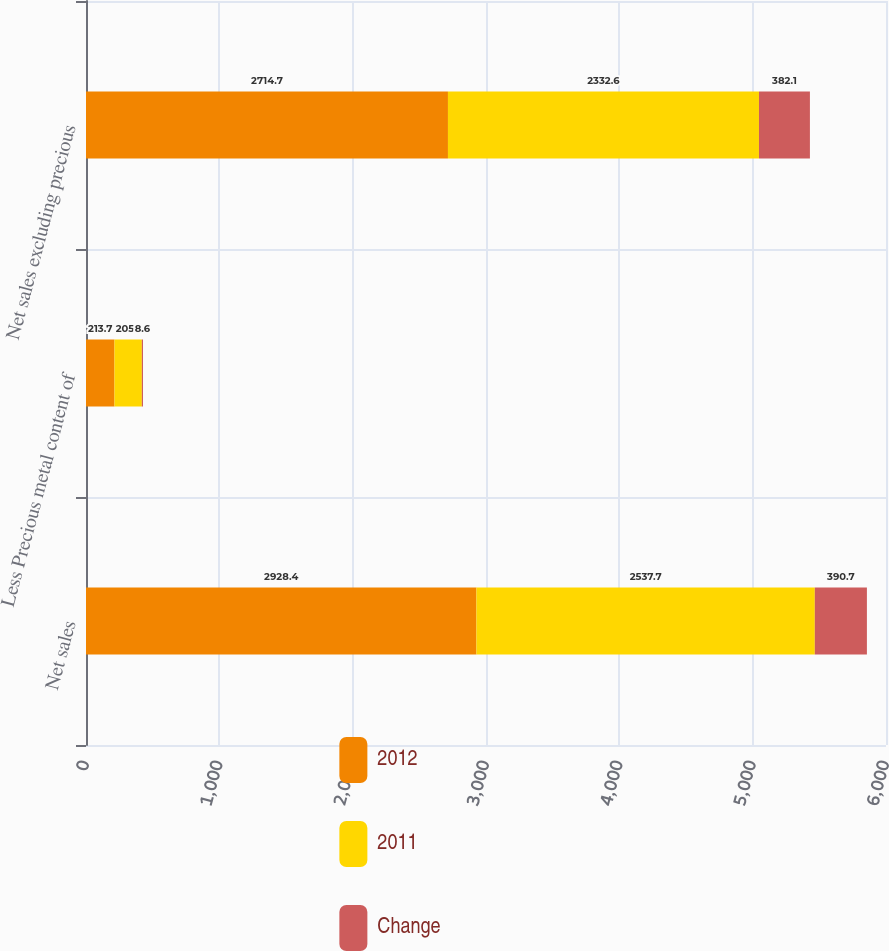<chart> <loc_0><loc_0><loc_500><loc_500><stacked_bar_chart><ecel><fcel>Net sales<fcel>Less Precious metal content of<fcel>Net sales excluding precious<nl><fcel>2012<fcel>2928.4<fcel>213.7<fcel>2714.7<nl><fcel>2011<fcel>2537.7<fcel>205.1<fcel>2332.6<nl><fcel>Change<fcel>390.7<fcel>8.6<fcel>382.1<nl></chart> 